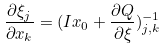Convert formula to latex. <formula><loc_0><loc_0><loc_500><loc_500>\frac { \partial \xi _ { j } } { \partial x _ { k } } = ( I x _ { 0 } + \frac { \partial Q } { \partial \xi } ) _ { j , k } ^ { - 1 }</formula> 